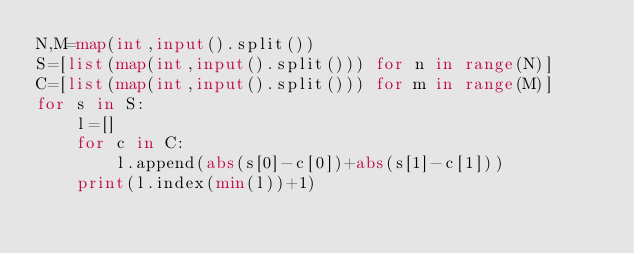<code> <loc_0><loc_0><loc_500><loc_500><_Python_>N,M=map(int,input().split())
S=[list(map(int,input().split())) for n in range(N)]
C=[list(map(int,input().split())) for m in range(M)]
for s in S:
    l=[]
    for c in C:
        l.append(abs(s[0]-c[0])+abs(s[1]-c[1]))
    print(l.index(min(l))+1)
</code> 